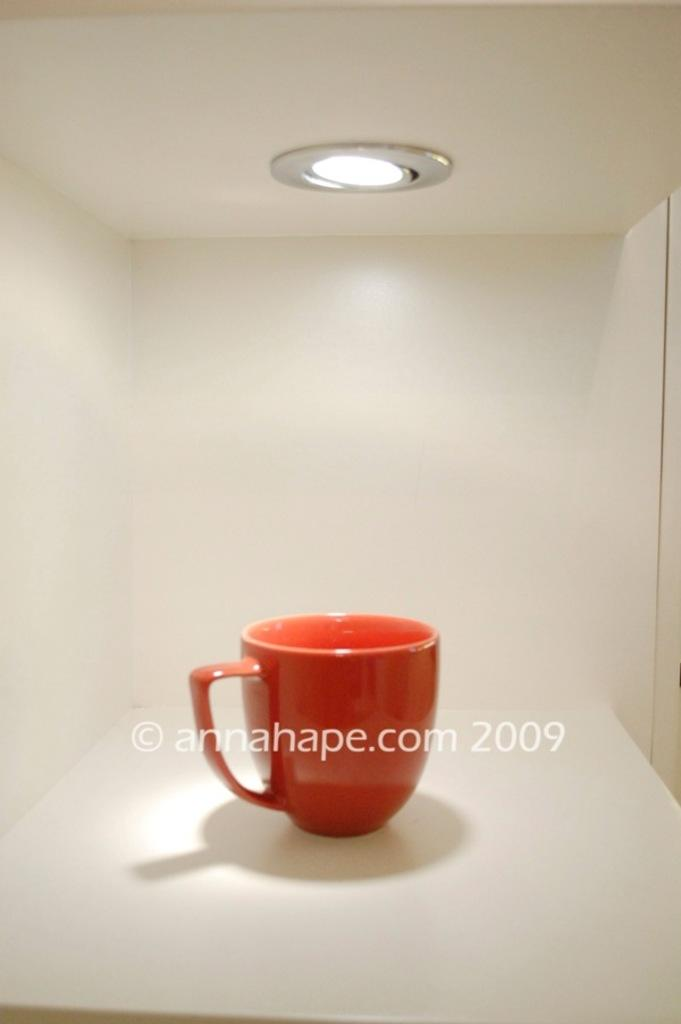What color is the cup that is visible in the image? There is a red cup in the image. What color is the background of the image? The background of the image is white. Can you describe the lighting in the image? There is a light present on the top of the image. How many volleyballs are visible in the image? There are no volleyballs present in the image. What type of office equipment can be seen in the image? There is no office equipment present in the image. 